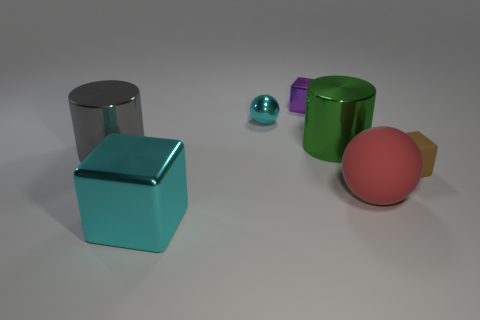Add 2 red spheres. How many objects exist? 9 Subtract all purple metallic cubes. How many cubes are left? 2 Subtract all brown blocks. How many blocks are left? 2 Subtract all cylinders. How many objects are left? 5 Subtract 2 spheres. How many spheres are left? 0 Subtract all brown cylinders. Subtract all gray cubes. How many cylinders are left? 2 Subtract all big cyan things. Subtract all big gray objects. How many objects are left? 5 Add 6 big red balls. How many big red balls are left? 7 Add 6 brown matte cylinders. How many brown matte cylinders exist? 6 Subtract 0 gray spheres. How many objects are left? 7 